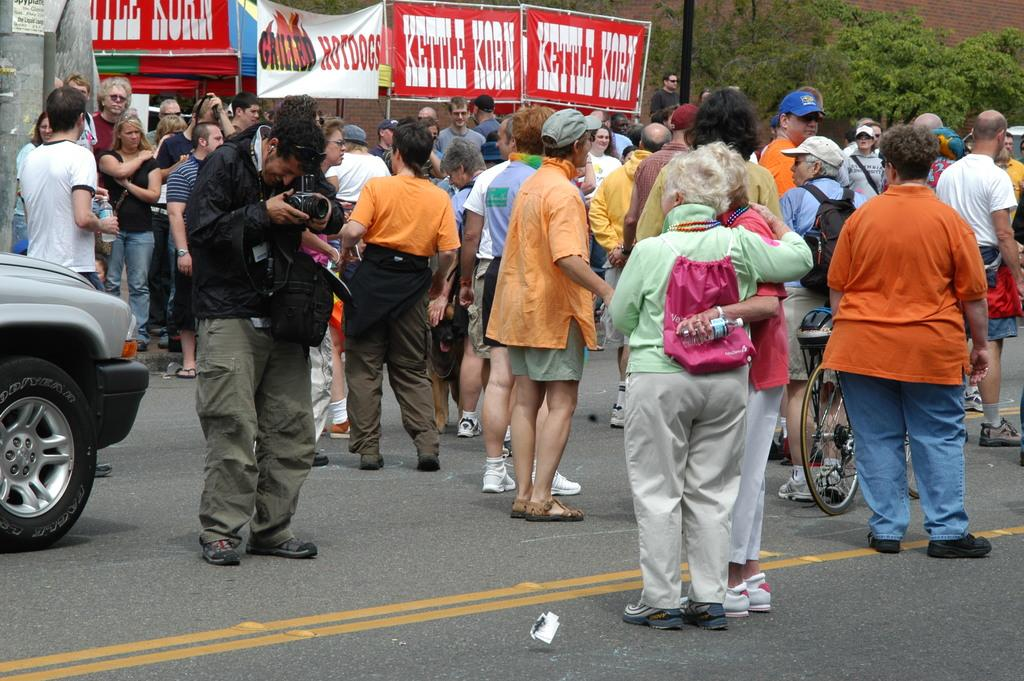What are the people in the image doing? The persons standing on the road in the image are likely waiting or walking. What vehicles are present in the image? There is a car and a bicycle in the image. What can be seen in the background of the image? There are banners and trees in the background of the image. What type of church can be seen in the image? There is no church present in the image. Can you describe the taste of the bicycle in the image? The bicycle in the image is not edible, so it does not have a taste. 